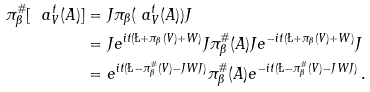<formula> <loc_0><loc_0><loc_500><loc_500>\pi _ { \beta } ^ { \# } [ \ a ^ { t } _ { V } ( A ) ] & = J \pi _ { \beta } ( \ a ^ { t } _ { V } ( A ) ) J \\ & = J e ^ { i t ( \L + \pi _ { \beta } ( V ) + W ) } J \pi _ { \beta } ^ { \# } ( A ) J e ^ { - i t ( \L + \pi _ { \beta } ( V ) + W ) } J \\ & = e ^ { i t ( \L - \pi _ { \beta } ^ { \# } ( V ) - J W J ) } \pi _ { \beta } ^ { \# } ( A ) e ^ { - i t ( \L - \pi _ { \beta } ^ { \# } ( V ) - J W J ) } \, .</formula> 